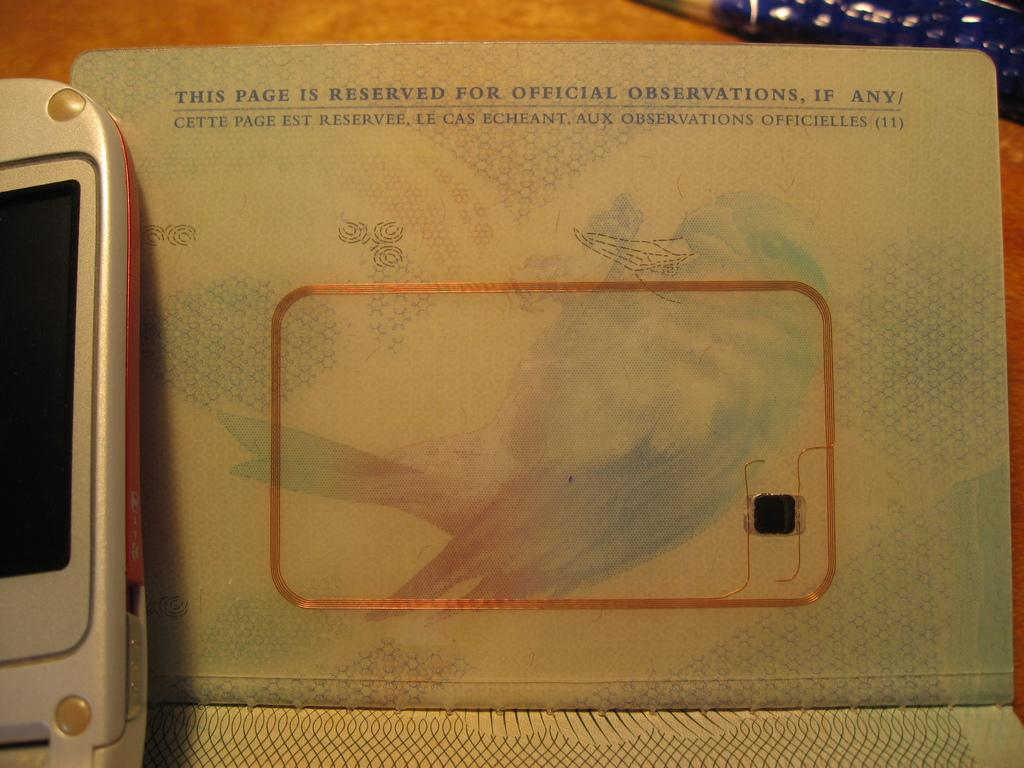<image>
Give a short and clear explanation of the subsequent image. A page with a faint bird design reserved for official observations sitting by a phone. 